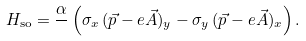<formula> <loc_0><loc_0><loc_500><loc_500>H _ { \text {so} } = \frac { \alpha } { } \left ( \sigma _ { x } \, ( \vec { p } - e \vec { A } ) _ { y } - \sigma _ { y } \, ( \vec { p } - e \vec { A } ) _ { x } \right ) .</formula> 